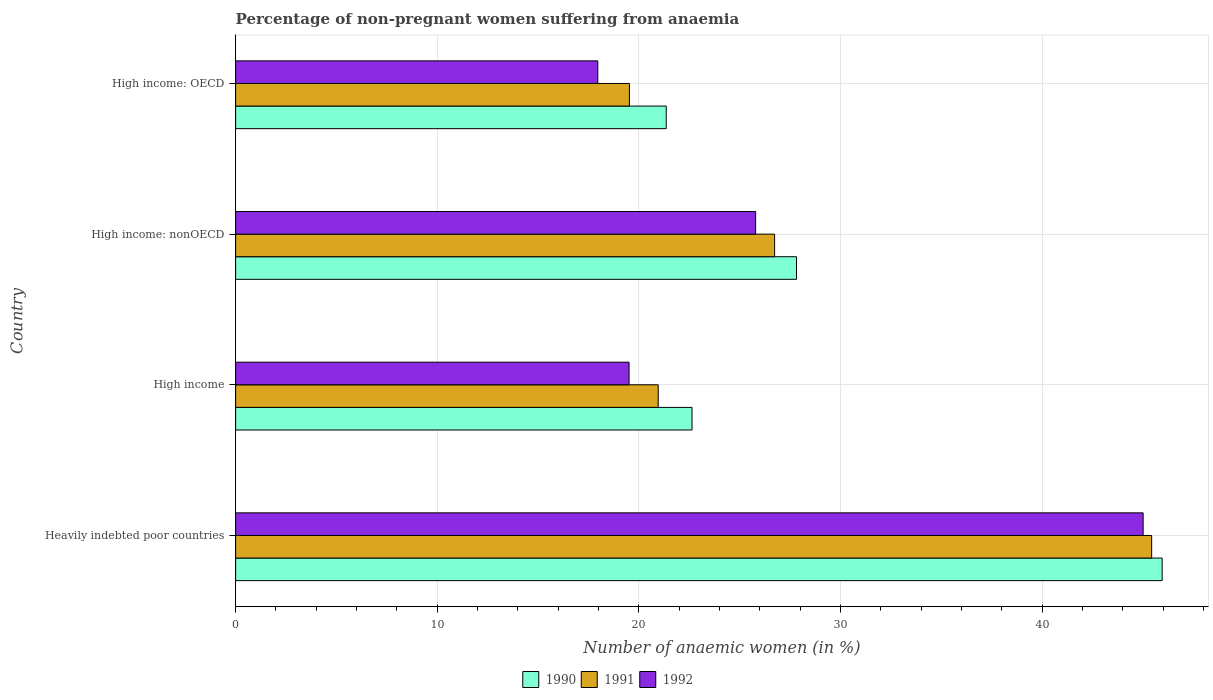How many groups of bars are there?
Provide a short and direct response. 4. How many bars are there on the 2nd tick from the top?
Make the answer very short. 3. How many bars are there on the 3rd tick from the bottom?
Your answer should be very brief. 3. What is the label of the 1st group of bars from the top?
Ensure brevity in your answer.  High income: OECD. In how many cases, is the number of bars for a given country not equal to the number of legend labels?
Offer a very short reply. 0. What is the percentage of non-pregnant women suffering from anaemia in 1991 in Heavily indebted poor countries?
Give a very brief answer. 45.44. Across all countries, what is the maximum percentage of non-pregnant women suffering from anaemia in 1991?
Your answer should be very brief. 45.44. Across all countries, what is the minimum percentage of non-pregnant women suffering from anaemia in 1992?
Your response must be concise. 17.96. In which country was the percentage of non-pregnant women suffering from anaemia in 1992 maximum?
Provide a succinct answer. Heavily indebted poor countries. In which country was the percentage of non-pregnant women suffering from anaemia in 1991 minimum?
Offer a terse response. High income: OECD. What is the total percentage of non-pregnant women suffering from anaemia in 1992 in the graph?
Provide a succinct answer. 108.28. What is the difference between the percentage of non-pregnant women suffering from anaemia in 1992 in High income and that in High income: OECD?
Provide a succinct answer. 1.55. What is the difference between the percentage of non-pregnant women suffering from anaemia in 1992 in Heavily indebted poor countries and the percentage of non-pregnant women suffering from anaemia in 1991 in High income: OECD?
Your answer should be compact. 25.48. What is the average percentage of non-pregnant women suffering from anaemia in 1992 per country?
Make the answer very short. 27.07. What is the difference between the percentage of non-pregnant women suffering from anaemia in 1990 and percentage of non-pregnant women suffering from anaemia in 1992 in High income: OECD?
Offer a terse response. 3.39. What is the ratio of the percentage of non-pregnant women suffering from anaemia in 1991 in Heavily indebted poor countries to that in High income?
Offer a very short reply. 2.17. Is the difference between the percentage of non-pregnant women suffering from anaemia in 1990 in Heavily indebted poor countries and High income: OECD greater than the difference between the percentage of non-pregnant women suffering from anaemia in 1992 in Heavily indebted poor countries and High income: OECD?
Offer a very short reply. No. What is the difference between the highest and the second highest percentage of non-pregnant women suffering from anaemia in 1991?
Offer a terse response. 18.7. What is the difference between the highest and the lowest percentage of non-pregnant women suffering from anaemia in 1990?
Ensure brevity in your answer.  24.6. Is the sum of the percentage of non-pregnant women suffering from anaemia in 1990 in Heavily indebted poor countries and High income: nonOECD greater than the maximum percentage of non-pregnant women suffering from anaemia in 1991 across all countries?
Offer a very short reply. Yes. What does the 3rd bar from the top in High income: OECD represents?
Provide a short and direct response. 1990. Is it the case that in every country, the sum of the percentage of non-pregnant women suffering from anaemia in 1992 and percentage of non-pregnant women suffering from anaemia in 1990 is greater than the percentage of non-pregnant women suffering from anaemia in 1991?
Your response must be concise. Yes. How many bars are there?
Give a very brief answer. 12. Are all the bars in the graph horizontal?
Provide a short and direct response. Yes. Does the graph contain any zero values?
Ensure brevity in your answer.  No. How many legend labels are there?
Give a very brief answer. 3. How are the legend labels stacked?
Give a very brief answer. Horizontal. What is the title of the graph?
Offer a terse response. Percentage of non-pregnant women suffering from anaemia. What is the label or title of the X-axis?
Make the answer very short. Number of anaemic women (in %). What is the label or title of the Y-axis?
Offer a very short reply. Country. What is the Number of anaemic women (in %) in 1990 in Heavily indebted poor countries?
Your answer should be compact. 45.96. What is the Number of anaemic women (in %) in 1991 in Heavily indebted poor countries?
Your answer should be compact. 45.44. What is the Number of anaemic women (in %) of 1992 in Heavily indebted poor countries?
Offer a terse response. 45.01. What is the Number of anaemic women (in %) in 1990 in High income?
Provide a short and direct response. 22.64. What is the Number of anaemic women (in %) in 1991 in High income?
Provide a short and direct response. 20.96. What is the Number of anaemic women (in %) of 1992 in High income?
Ensure brevity in your answer.  19.51. What is the Number of anaemic women (in %) in 1990 in High income: nonOECD?
Your response must be concise. 27.82. What is the Number of anaemic women (in %) in 1991 in High income: nonOECD?
Your answer should be very brief. 26.73. What is the Number of anaemic women (in %) of 1992 in High income: nonOECD?
Your response must be concise. 25.79. What is the Number of anaemic women (in %) of 1990 in High income: OECD?
Make the answer very short. 21.36. What is the Number of anaemic women (in %) in 1991 in High income: OECD?
Give a very brief answer. 19.53. What is the Number of anaemic women (in %) of 1992 in High income: OECD?
Ensure brevity in your answer.  17.96. Across all countries, what is the maximum Number of anaemic women (in %) of 1990?
Offer a terse response. 45.96. Across all countries, what is the maximum Number of anaemic women (in %) of 1991?
Offer a very short reply. 45.44. Across all countries, what is the maximum Number of anaemic women (in %) in 1992?
Make the answer very short. 45.01. Across all countries, what is the minimum Number of anaemic women (in %) in 1990?
Offer a very short reply. 21.36. Across all countries, what is the minimum Number of anaemic women (in %) in 1991?
Offer a terse response. 19.53. Across all countries, what is the minimum Number of anaemic women (in %) of 1992?
Offer a terse response. 17.96. What is the total Number of anaemic women (in %) in 1990 in the graph?
Give a very brief answer. 117.77. What is the total Number of anaemic women (in %) of 1991 in the graph?
Your answer should be very brief. 112.66. What is the total Number of anaemic women (in %) of 1992 in the graph?
Your answer should be compact. 108.28. What is the difference between the Number of anaemic women (in %) in 1990 in Heavily indebted poor countries and that in High income?
Ensure brevity in your answer.  23.32. What is the difference between the Number of anaemic women (in %) in 1991 in Heavily indebted poor countries and that in High income?
Ensure brevity in your answer.  24.47. What is the difference between the Number of anaemic women (in %) of 1992 in Heavily indebted poor countries and that in High income?
Keep it short and to the point. 25.5. What is the difference between the Number of anaemic women (in %) of 1990 in Heavily indebted poor countries and that in High income: nonOECD?
Provide a succinct answer. 18.14. What is the difference between the Number of anaemic women (in %) of 1991 in Heavily indebted poor countries and that in High income: nonOECD?
Ensure brevity in your answer.  18.7. What is the difference between the Number of anaemic women (in %) of 1992 in Heavily indebted poor countries and that in High income: nonOECD?
Make the answer very short. 19.22. What is the difference between the Number of anaemic women (in %) in 1990 in Heavily indebted poor countries and that in High income: OECD?
Make the answer very short. 24.6. What is the difference between the Number of anaemic women (in %) of 1991 in Heavily indebted poor countries and that in High income: OECD?
Your answer should be compact. 25.9. What is the difference between the Number of anaemic women (in %) of 1992 in Heavily indebted poor countries and that in High income: OECD?
Ensure brevity in your answer.  27.05. What is the difference between the Number of anaemic women (in %) in 1990 in High income and that in High income: nonOECD?
Give a very brief answer. -5.18. What is the difference between the Number of anaemic women (in %) of 1991 in High income and that in High income: nonOECD?
Your response must be concise. -5.77. What is the difference between the Number of anaemic women (in %) of 1992 in High income and that in High income: nonOECD?
Keep it short and to the point. -6.28. What is the difference between the Number of anaemic women (in %) of 1990 in High income and that in High income: OECD?
Make the answer very short. 1.28. What is the difference between the Number of anaemic women (in %) of 1991 in High income and that in High income: OECD?
Your response must be concise. 1.43. What is the difference between the Number of anaemic women (in %) of 1992 in High income and that in High income: OECD?
Your answer should be very brief. 1.55. What is the difference between the Number of anaemic women (in %) of 1990 in High income: nonOECD and that in High income: OECD?
Ensure brevity in your answer.  6.46. What is the difference between the Number of anaemic women (in %) in 1991 in High income: nonOECD and that in High income: OECD?
Your response must be concise. 7.2. What is the difference between the Number of anaemic women (in %) in 1992 in High income: nonOECD and that in High income: OECD?
Provide a short and direct response. 7.83. What is the difference between the Number of anaemic women (in %) in 1990 in Heavily indebted poor countries and the Number of anaemic women (in %) in 1991 in High income?
Give a very brief answer. 25. What is the difference between the Number of anaemic women (in %) of 1990 in Heavily indebted poor countries and the Number of anaemic women (in %) of 1992 in High income?
Provide a short and direct response. 26.44. What is the difference between the Number of anaemic women (in %) of 1991 in Heavily indebted poor countries and the Number of anaemic women (in %) of 1992 in High income?
Keep it short and to the point. 25.92. What is the difference between the Number of anaemic women (in %) of 1990 in Heavily indebted poor countries and the Number of anaemic women (in %) of 1991 in High income: nonOECD?
Provide a succinct answer. 19.22. What is the difference between the Number of anaemic women (in %) in 1990 in Heavily indebted poor countries and the Number of anaemic women (in %) in 1992 in High income: nonOECD?
Provide a succinct answer. 20.16. What is the difference between the Number of anaemic women (in %) of 1991 in Heavily indebted poor countries and the Number of anaemic women (in %) of 1992 in High income: nonOECD?
Your answer should be very brief. 19.64. What is the difference between the Number of anaemic women (in %) of 1990 in Heavily indebted poor countries and the Number of anaemic women (in %) of 1991 in High income: OECD?
Give a very brief answer. 26.42. What is the difference between the Number of anaemic women (in %) in 1990 in Heavily indebted poor countries and the Number of anaemic women (in %) in 1992 in High income: OECD?
Provide a succinct answer. 27.99. What is the difference between the Number of anaemic women (in %) in 1991 in Heavily indebted poor countries and the Number of anaemic women (in %) in 1992 in High income: OECD?
Ensure brevity in your answer.  27.47. What is the difference between the Number of anaemic women (in %) in 1990 in High income and the Number of anaemic women (in %) in 1991 in High income: nonOECD?
Your response must be concise. -4.1. What is the difference between the Number of anaemic women (in %) in 1990 in High income and the Number of anaemic women (in %) in 1992 in High income: nonOECD?
Provide a short and direct response. -3.15. What is the difference between the Number of anaemic women (in %) of 1991 in High income and the Number of anaemic women (in %) of 1992 in High income: nonOECD?
Your response must be concise. -4.83. What is the difference between the Number of anaemic women (in %) in 1990 in High income and the Number of anaemic women (in %) in 1991 in High income: OECD?
Your response must be concise. 3.11. What is the difference between the Number of anaemic women (in %) in 1990 in High income and the Number of anaemic women (in %) in 1992 in High income: OECD?
Your answer should be very brief. 4.67. What is the difference between the Number of anaemic women (in %) in 1991 in High income and the Number of anaemic women (in %) in 1992 in High income: OECD?
Offer a very short reply. 3. What is the difference between the Number of anaemic women (in %) of 1990 in High income: nonOECD and the Number of anaemic women (in %) of 1991 in High income: OECD?
Provide a short and direct response. 8.29. What is the difference between the Number of anaemic women (in %) of 1990 in High income: nonOECD and the Number of anaemic women (in %) of 1992 in High income: OECD?
Provide a short and direct response. 9.86. What is the difference between the Number of anaemic women (in %) in 1991 in High income: nonOECD and the Number of anaemic women (in %) in 1992 in High income: OECD?
Give a very brief answer. 8.77. What is the average Number of anaemic women (in %) in 1990 per country?
Offer a very short reply. 29.44. What is the average Number of anaemic women (in %) of 1991 per country?
Keep it short and to the point. 28.17. What is the average Number of anaemic women (in %) in 1992 per country?
Offer a very short reply. 27.07. What is the difference between the Number of anaemic women (in %) of 1990 and Number of anaemic women (in %) of 1991 in Heavily indebted poor countries?
Give a very brief answer. 0.52. What is the difference between the Number of anaemic women (in %) in 1990 and Number of anaemic women (in %) in 1992 in Heavily indebted poor countries?
Your answer should be very brief. 0.94. What is the difference between the Number of anaemic women (in %) in 1991 and Number of anaemic women (in %) in 1992 in Heavily indebted poor countries?
Provide a short and direct response. 0.42. What is the difference between the Number of anaemic women (in %) of 1990 and Number of anaemic women (in %) of 1991 in High income?
Offer a very short reply. 1.68. What is the difference between the Number of anaemic women (in %) of 1990 and Number of anaemic women (in %) of 1992 in High income?
Provide a short and direct response. 3.12. What is the difference between the Number of anaemic women (in %) of 1991 and Number of anaemic women (in %) of 1992 in High income?
Ensure brevity in your answer.  1.45. What is the difference between the Number of anaemic women (in %) in 1990 and Number of anaemic women (in %) in 1991 in High income: nonOECD?
Provide a succinct answer. 1.09. What is the difference between the Number of anaemic women (in %) of 1990 and Number of anaemic women (in %) of 1992 in High income: nonOECD?
Provide a succinct answer. 2.03. What is the difference between the Number of anaemic women (in %) in 1991 and Number of anaemic women (in %) in 1992 in High income: nonOECD?
Offer a very short reply. 0.94. What is the difference between the Number of anaemic women (in %) of 1990 and Number of anaemic women (in %) of 1991 in High income: OECD?
Provide a short and direct response. 1.83. What is the difference between the Number of anaemic women (in %) in 1990 and Number of anaemic women (in %) in 1992 in High income: OECD?
Give a very brief answer. 3.39. What is the difference between the Number of anaemic women (in %) in 1991 and Number of anaemic women (in %) in 1992 in High income: OECD?
Ensure brevity in your answer.  1.57. What is the ratio of the Number of anaemic women (in %) of 1990 in Heavily indebted poor countries to that in High income?
Provide a short and direct response. 2.03. What is the ratio of the Number of anaemic women (in %) in 1991 in Heavily indebted poor countries to that in High income?
Your response must be concise. 2.17. What is the ratio of the Number of anaemic women (in %) of 1992 in Heavily indebted poor countries to that in High income?
Make the answer very short. 2.31. What is the ratio of the Number of anaemic women (in %) of 1990 in Heavily indebted poor countries to that in High income: nonOECD?
Give a very brief answer. 1.65. What is the ratio of the Number of anaemic women (in %) in 1991 in Heavily indebted poor countries to that in High income: nonOECD?
Your answer should be very brief. 1.7. What is the ratio of the Number of anaemic women (in %) in 1992 in Heavily indebted poor countries to that in High income: nonOECD?
Make the answer very short. 1.75. What is the ratio of the Number of anaemic women (in %) of 1990 in Heavily indebted poor countries to that in High income: OECD?
Offer a terse response. 2.15. What is the ratio of the Number of anaemic women (in %) in 1991 in Heavily indebted poor countries to that in High income: OECD?
Your response must be concise. 2.33. What is the ratio of the Number of anaemic women (in %) of 1992 in Heavily indebted poor countries to that in High income: OECD?
Your answer should be very brief. 2.51. What is the ratio of the Number of anaemic women (in %) in 1990 in High income to that in High income: nonOECD?
Provide a short and direct response. 0.81. What is the ratio of the Number of anaemic women (in %) in 1991 in High income to that in High income: nonOECD?
Your response must be concise. 0.78. What is the ratio of the Number of anaemic women (in %) of 1992 in High income to that in High income: nonOECD?
Your response must be concise. 0.76. What is the ratio of the Number of anaemic women (in %) of 1990 in High income to that in High income: OECD?
Your answer should be compact. 1.06. What is the ratio of the Number of anaemic women (in %) of 1991 in High income to that in High income: OECD?
Ensure brevity in your answer.  1.07. What is the ratio of the Number of anaemic women (in %) of 1992 in High income to that in High income: OECD?
Ensure brevity in your answer.  1.09. What is the ratio of the Number of anaemic women (in %) of 1990 in High income: nonOECD to that in High income: OECD?
Your response must be concise. 1.3. What is the ratio of the Number of anaemic women (in %) of 1991 in High income: nonOECD to that in High income: OECD?
Your answer should be very brief. 1.37. What is the ratio of the Number of anaemic women (in %) in 1992 in High income: nonOECD to that in High income: OECD?
Offer a terse response. 1.44. What is the difference between the highest and the second highest Number of anaemic women (in %) of 1990?
Your response must be concise. 18.14. What is the difference between the highest and the second highest Number of anaemic women (in %) of 1991?
Offer a very short reply. 18.7. What is the difference between the highest and the second highest Number of anaemic women (in %) in 1992?
Give a very brief answer. 19.22. What is the difference between the highest and the lowest Number of anaemic women (in %) of 1990?
Offer a very short reply. 24.6. What is the difference between the highest and the lowest Number of anaemic women (in %) in 1991?
Provide a succinct answer. 25.9. What is the difference between the highest and the lowest Number of anaemic women (in %) of 1992?
Your answer should be very brief. 27.05. 